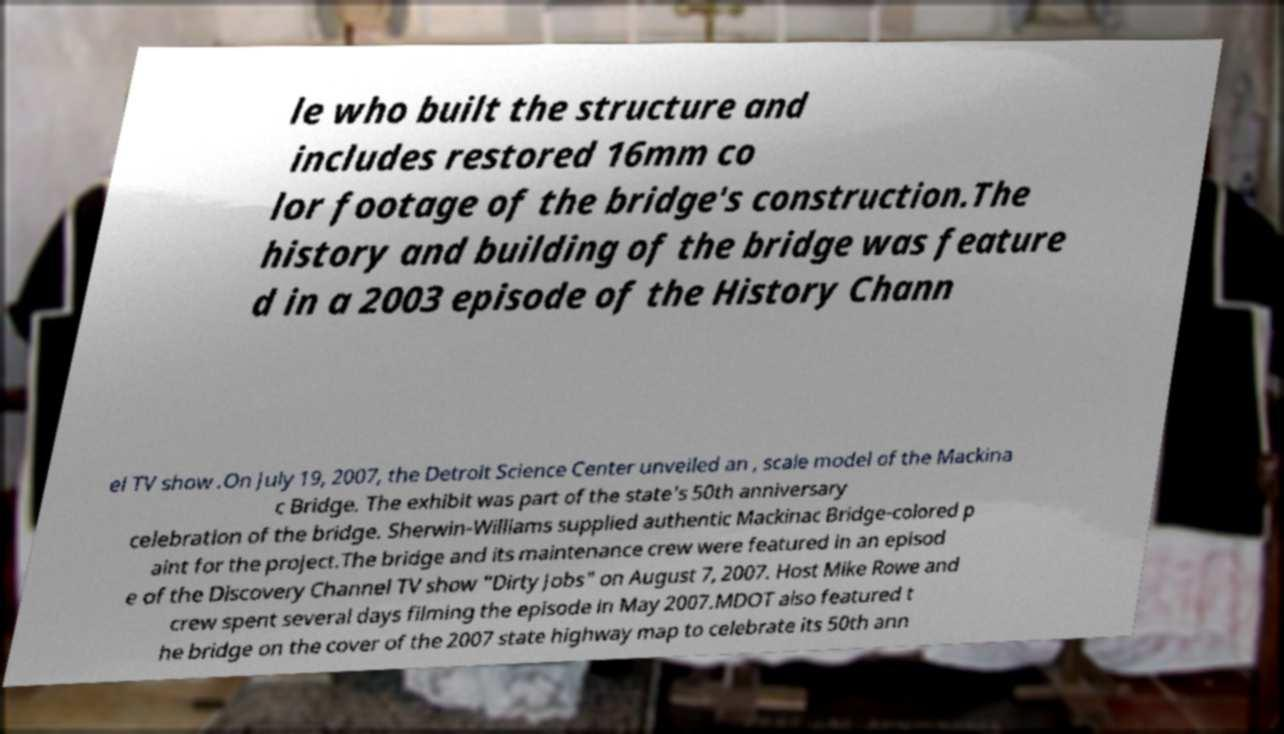Could you extract and type out the text from this image? le who built the structure and includes restored 16mm co lor footage of the bridge's construction.The history and building of the bridge was feature d in a 2003 episode of the History Chann el TV show .On July 19, 2007, the Detroit Science Center unveiled an , scale model of the Mackina c Bridge. The exhibit was part of the state's 50th anniversary celebration of the bridge. Sherwin-Williams supplied authentic Mackinac Bridge-colored p aint for the project.The bridge and its maintenance crew were featured in an episod e of the Discovery Channel TV show "Dirty Jobs" on August 7, 2007. Host Mike Rowe and crew spent several days filming the episode in May 2007.MDOT also featured t he bridge on the cover of the 2007 state highway map to celebrate its 50th ann 